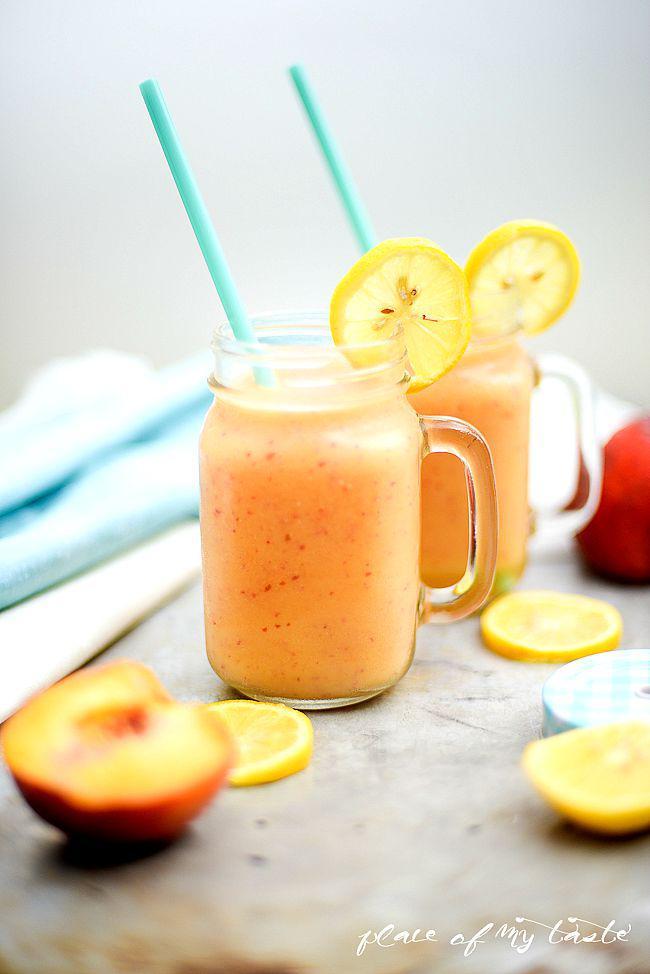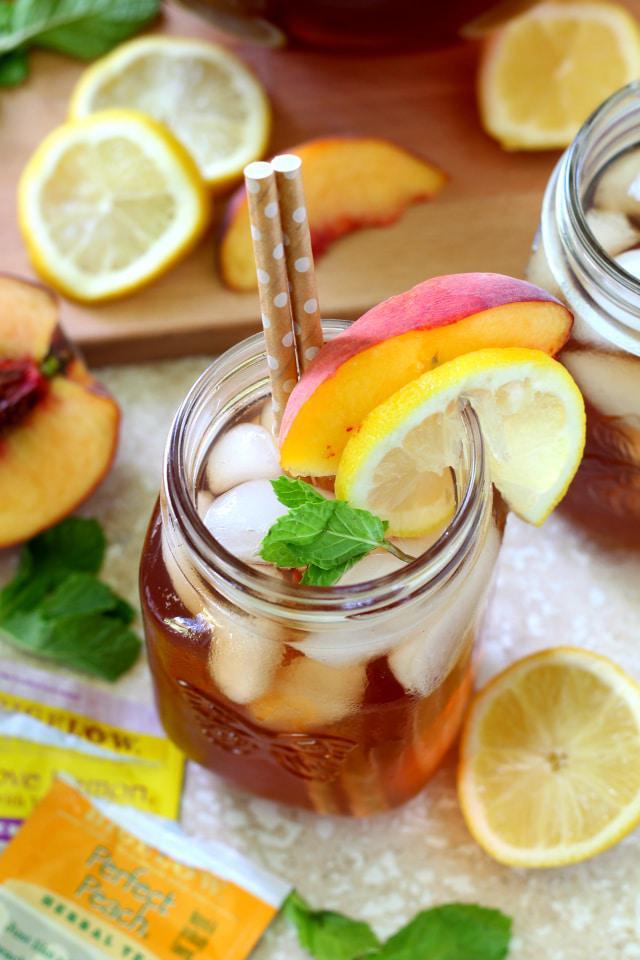The first image is the image on the left, the second image is the image on the right. Analyze the images presented: Is the assertion "A slice of citrus garnishes the drink in at least one of the images." valid? Answer yes or no. Yes. The first image is the image on the left, the second image is the image on the right. For the images shown, is this caption "An image shows at least one glass of creamy peach-colored beverage next to peach fruit." true? Answer yes or no. Yes. 